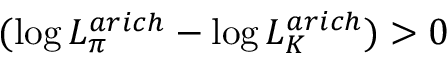Convert formula to latex. <formula><loc_0><loc_0><loc_500><loc_500>( \log { L _ { \pi } ^ { a r i c h } } - \log { L _ { K } ^ { a r i c h } ) } > 0</formula> 